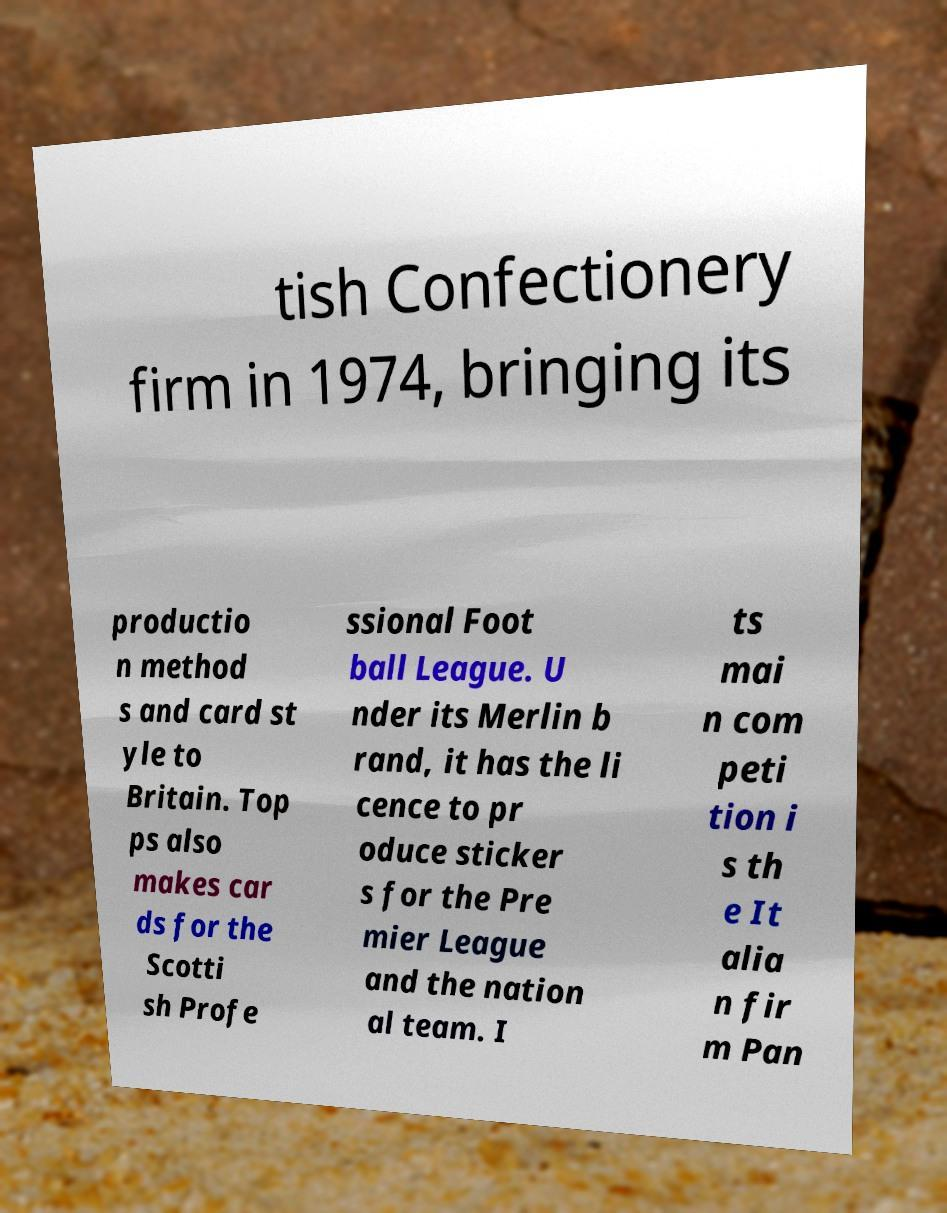What messages or text are displayed in this image? I need them in a readable, typed format. tish Confectionery firm in 1974, bringing its productio n method s and card st yle to Britain. Top ps also makes car ds for the Scotti sh Profe ssional Foot ball League. U nder its Merlin b rand, it has the li cence to pr oduce sticker s for the Pre mier League and the nation al team. I ts mai n com peti tion i s th e It alia n fir m Pan 